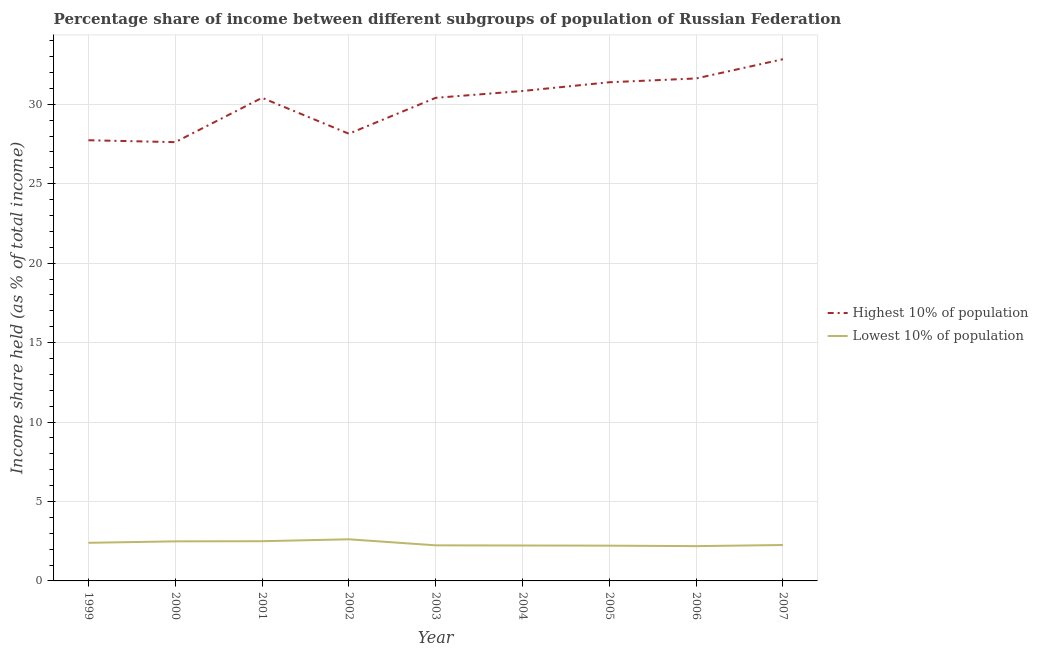Does the line corresponding to income share held by highest 10% of the population intersect with the line corresponding to income share held by lowest 10% of the population?
Make the answer very short. No. Is the number of lines equal to the number of legend labels?
Provide a succinct answer. Yes. What is the income share held by lowest 10% of the population in 2006?
Offer a very short reply. 2.19. Across all years, what is the maximum income share held by lowest 10% of the population?
Offer a very short reply. 2.62. Across all years, what is the minimum income share held by lowest 10% of the population?
Keep it short and to the point. 2.19. In which year was the income share held by lowest 10% of the population minimum?
Keep it short and to the point. 2006. What is the total income share held by lowest 10% of the population in the graph?
Make the answer very short. 21.15. What is the difference between the income share held by highest 10% of the population in 2004 and that in 2006?
Provide a succinct answer. -0.79. What is the difference between the income share held by highest 10% of the population in 2001 and the income share held by lowest 10% of the population in 2007?
Your answer should be compact. 28.15. What is the average income share held by lowest 10% of the population per year?
Your response must be concise. 2.35. In the year 2003, what is the difference between the income share held by lowest 10% of the population and income share held by highest 10% of the population?
Offer a very short reply. -28.17. What is the ratio of the income share held by lowest 10% of the population in 2000 to that in 2006?
Offer a terse response. 1.14. Is the income share held by highest 10% of the population in 2002 less than that in 2005?
Provide a short and direct response. Yes. Is the difference between the income share held by lowest 10% of the population in 2003 and 2006 greater than the difference between the income share held by highest 10% of the population in 2003 and 2006?
Offer a very short reply. Yes. What is the difference between the highest and the second highest income share held by highest 10% of the population?
Your response must be concise. 1.21. What is the difference between the highest and the lowest income share held by highest 10% of the population?
Ensure brevity in your answer.  5.22. Is the sum of the income share held by highest 10% of the population in 2001 and 2005 greater than the maximum income share held by lowest 10% of the population across all years?
Ensure brevity in your answer.  Yes. Does the income share held by highest 10% of the population monotonically increase over the years?
Make the answer very short. No. Is the income share held by highest 10% of the population strictly greater than the income share held by lowest 10% of the population over the years?
Offer a terse response. Yes. What is the difference between two consecutive major ticks on the Y-axis?
Your answer should be very brief. 5. Are the values on the major ticks of Y-axis written in scientific E-notation?
Offer a very short reply. No. Does the graph contain grids?
Give a very brief answer. Yes. Where does the legend appear in the graph?
Give a very brief answer. Center right. How are the legend labels stacked?
Provide a succinct answer. Vertical. What is the title of the graph?
Provide a short and direct response. Percentage share of income between different subgroups of population of Russian Federation. Does "Nonresident" appear as one of the legend labels in the graph?
Your answer should be very brief. No. What is the label or title of the Y-axis?
Your response must be concise. Income share held (as % of total income). What is the Income share held (as % of total income) of Highest 10% of population in 1999?
Provide a short and direct response. 27.74. What is the Income share held (as % of total income) in Highest 10% of population in 2000?
Your answer should be compact. 27.62. What is the Income share held (as % of total income) of Lowest 10% of population in 2000?
Provide a succinct answer. 2.49. What is the Income share held (as % of total income) of Highest 10% of population in 2001?
Offer a very short reply. 30.41. What is the Income share held (as % of total income) in Lowest 10% of population in 2001?
Keep it short and to the point. 2.5. What is the Income share held (as % of total income) of Highest 10% of population in 2002?
Ensure brevity in your answer.  28.15. What is the Income share held (as % of total income) of Lowest 10% of population in 2002?
Your answer should be very brief. 2.62. What is the Income share held (as % of total income) in Highest 10% of population in 2003?
Give a very brief answer. 30.41. What is the Income share held (as % of total income) in Lowest 10% of population in 2003?
Your answer should be compact. 2.24. What is the Income share held (as % of total income) of Highest 10% of population in 2004?
Ensure brevity in your answer.  30.84. What is the Income share held (as % of total income) in Lowest 10% of population in 2004?
Your response must be concise. 2.23. What is the Income share held (as % of total income) of Highest 10% of population in 2005?
Keep it short and to the point. 31.39. What is the Income share held (as % of total income) in Lowest 10% of population in 2005?
Your answer should be compact. 2.22. What is the Income share held (as % of total income) in Highest 10% of population in 2006?
Offer a terse response. 31.63. What is the Income share held (as % of total income) in Lowest 10% of population in 2006?
Give a very brief answer. 2.19. What is the Income share held (as % of total income) in Highest 10% of population in 2007?
Give a very brief answer. 32.84. What is the Income share held (as % of total income) of Lowest 10% of population in 2007?
Your response must be concise. 2.26. Across all years, what is the maximum Income share held (as % of total income) of Highest 10% of population?
Ensure brevity in your answer.  32.84. Across all years, what is the maximum Income share held (as % of total income) of Lowest 10% of population?
Make the answer very short. 2.62. Across all years, what is the minimum Income share held (as % of total income) of Highest 10% of population?
Ensure brevity in your answer.  27.62. Across all years, what is the minimum Income share held (as % of total income) of Lowest 10% of population?
Ensure brevity in your answer.  2.19. What is the total Income share held (as % of total income) of Highest 10% of population in the graph?
Make the answer very short. 271.03. What is the total Income share held (as % of total income) of Lowest 10% of population in the graph?
Offer a terse response. 21.15. What is the difference between the Income share held (as % of total income) in Highest 10% of population in 1999 and that in 2000?
Offer a terse response. 0.12. What is the difference between the Income share held (as % of total income) of Lowest 10% of population in 1999 and that in 2000?
Ensure brevity in your answer.  -0.09. What is the difference between the Income share held (as % of total income) in Highest 10% of population in 1999 and that in 2001?
Your answer should be very brief. -2.67. What is the difference between the Income share held (as % of total income) in Lowest 10% of population in 1999 and that in 2001?
Make the answer very short. -0.1. What is the difference between the Income share held (as % of total income) in Highest 10% of population in 1999 and that in 2002?
Provide a succinct answer. -0.41. What is the difference between the Income share held (as % of total income) in Lowest 10% of population in 1999 and that in 2002?
Your answer should be very brief. -0.22. What is the difference between the Income share held (as % of total income) of Highest 10% of population in 1999 and that in 2003?
Provide a succinct answer. -2.67. What is the difference between the Income share held (as % of total income) in Lowest 10% of population in 1999 and that in 2003?
Provide a short and direct response. 0.16. What is the difference between the Income share held (as % of total income) of Highest 10% of population in 1999 and that in 2004?
Provide a succinct answer. -3.1. What is the difference between the Income share held (as % of total income) of Lowest 10% of population in 1999 and that in 2004?
Keep it short and to the point. 0.17. What is the difference between the Income share held (as % of total income) of Highest 10% of population in 1999 and that in 2005?
Make the answer very short. -3.65. What is the difference between the Income share held (as % of total income) of Lowest 10% of population in 1999 and that in 2005?
Your answer should be compact. 0.18. What is the difference between the Income share held (as % of total income) of Highest 10% of population in 1999 and that in 2006?
Provide a short and direct response. -3.89. What is the difference between the Income share held (as % of total income) in Lowest 10% of population in 1999 and that in 2006?
Your answer should be compact. 0.21. What is the difference between the Income share held (as % of total income) in Lowest 10% of population in 1999 and that in 2007?
Make the answer very short. 0.14. What is the difference between the Income share held (as % of total income) in Highest 10% of population in 2000 and that in 2001?
Provide a succinct answer. -2.79. What is the difference between the Income share held (as % of total income) in Lowest 10% of population in 2000 and that in 2001?
Your answer should be very brief. -0.01. What is the difference between the Income share held (as % of total income) in Highest 10% of population in 2000 and that in 2002?
Provide a short and direct response. -0.53. What is the difference between the Income share held (as % of total income) in Lowest 10% of population in 2000 and that in 2002?
Provide a short and direct response. -0.13. What is the difference between the Income share held (as % of total income) in Highest 10% of population in 2000 and that in 2003?
Offer a terse response. -2.79. What is the difference between the Income share held (as % of total income) of Lowest 10% of population in 2000 and that in 2003?
Ensure brevity in your answer.  0.25. What is the difference between the Income share held (as % of total income) in Highest 10% of population in 2000 and that in 2004?
Make the answer very short. -3.22. What is the difference between the Income share held (as % of total income) of Lowest 10% of population in 2000 and that in 2004?
Provide a succinct answer. 0.26. What is the difference between the Income share held (as % of total income) in Highest 10% of population in 2000 and that in 2005?
Ensure brevity in your answer.  -3.77. What is the difference between the Income share held (as % of total income) of Lowest 10% of population in 2000 and that in 2005?
Ensure brevity in your answer.  0.27. What is the difference between the Income share held (as % of total income) of Highest 10% of population in 2000 and that in 2006?
Make the answer very short. -4.01. What is the difference between the Income share held (as % of total income) in Highest 10% of population in 2000 and that in 2007?
Your answer should be very brief. -5.22. What is the difference between the Income share held (as % of total income) in Lowest 10% of population in 2000 and that in 2007?
Provide a short and direct response. 0.23. What is the difference between the Income share held (as % of total income) in Highest 10% of population in 2001 and that in 2002?
Give a very brief answer. 2.26. What is the difference between the Income share held (as % of total income) in Lowest 10% of population in 2001 and that in 2002?
Make the answer very short. -0.12. What is the difference between the Income share held (as % of total income) of Highest 10% of population in 2001 and that in 2003?
Keep it short and to the point. 0. What is the difference between the Income share held (as % of total income) in Lowest 10% of population in 2001 and that in 2003?
Keep it short and to the point. 0.26. What is the difference between the Income share held (as % of total income) of Highest 10% of population in 2001 and that in 2004?
Your response must be concise. -0.43. What is the difference between the Income share held (as % of total income) in Lowest 10% of population in 2001 and that in 2004?
Provide a short and direct response. 0.27. What is the difference between the Income share held (as % of total income) in Highest 10% of population in 2001 and that in 2005?
Your answer should be compact. -0.98. What is the difference between the Income share held (as % of total income) of Lowest 10% of population in 2001 and that in 2005?
Provide a succinct answer. 0.28. What is the difference between the Income share held (as % of total income) of Highest 10% of population in 2001 and that in 2006?
Provide a short and direct response. -1.22. What is the difference between the Income share held (as % of total income) in Lowest 10% of population in 2001 and that in 2006?
Provide a short and direct response. 0.31. What is the difference between the Income share held (as % of total income) of Highest 10% of population in 2001 and that in 2007?
Make the answer very short. -2.43. What is the difference between the Income share held (as % of total income) in Lowest 10% of population in 2001 and that in 2007?
Ensure brevity in your answer.  0.24. What is the difference between the Income share held (as % of total income) of Highest 10% of population in 2002 and that in 2003?
Make the answer very short. -2.26. What is the difference between the Income share held (as % of total income) in Lowest 10% of population in 2002 and that in 2003?
Offer a terse response. 0.38. What is the difference between the Income share held (as % of total income) in Highest 10% of population in 2002 and that in 2004?
Offer a very short reply. -2.69. What is the difference between the Income share held (as % of total income) of Lowest 10% of population in 2002 and that in 2004?
Give a very brief answer. 0.39. What is the difference between the Income share held (as % of total income) of Highest 10% of population in 2002 and that in 2005?
Keep it short and to the point. -3.24. What is the difference between the Income share held (as % of total income) of Highest 10% of population in 2002 and that in 2006?
Your answer should be compact. -3.48. What is the difference between the Income share held (as % of total income) of Lowest 10% of population in 2002 and that in 2006?
Your answer should be very brief. 0.43. What is the difference between the Income share held (as % of total income) in Highest 10% of population in 2002 and that in 2007?
Your answer should be very brief. -4.69. What is the difference between the Income share held (as % of total income) in Lowest 10% of population in 2002 and that in 2007?
Ensure brevity in your answer.  0.36. What is the difference between the Income share held (as % of total income) in Highest 10% of population in 2003 and that in 2004?
Give a very brief answer. -0.43. What is the difference between the Income share held (as % of total income) of Lowest 10% of population in 2003 and that in 2004?
Keep it short and to the point. 0.01. What is the difference between the Income share held (as % of total income) of Highest 10% of population in 2003 and that in 2005?
Your answer should be very brief. -0.98. What is the difference between the Income share held (as % of total income) of Highest 10% of population in 2003 and that in 2006?
Make the answer very short. -1.22. What is the difference between the Income share held (as % of total income) in Lowest 10% of population in 2003 and that in 2006?
Provide a succinct answer. 0.05. What is the difference between the Income share held (as % of total income) in Highest 10% of population in 2003 and that in 2007?
Your answer should be very brief. -2.43. What is the difference between the Income share held (as % of total income) of Lowest 10% of population in 2003 and that in 2007?
Your answer should be very brief. -0.02. What is the difference between the Income share held (as % of total income) of Highest 10% of population in 2004 and that in 2005?
Offer a very short reply. -0.55. What is the difference between the Income share held (as % of total income) in Lowest 10% of population in 2004 and that in 2005?
Provide a short and direct response. 0.01. What is the difference between the Income share held (as % of total income) of Highest 10% of population in 2004 and that in 2006?
Ensure brevity in your answer.  -0.79. What is the difference between the Income share held (as % of total income) of Lowest 10% of population in 2004 and that in 2006?
Keep it short and to the point. 0.04. What is the difference between the Income share held (as % of total income) of Highest 10% of population in 2004 and that in 2007?
Offer a terse response. -2. What is the difference between the Income share held (as % of total income) in Lowest 10% of population in 2004 and that in 2007?
Your answer should be very brief. -0.03. What is the difference between the Income share held (as % of total income) in Highest 10% of population in 2005 and that in 2006?
Your answer should be very brief. -0.24. What is the difference between the Income share held (as % of total income) in Highest 10% of population in 2005 and that in 2007?
Make the answer very short. -1.45. What is the difference between the Income share held (as % of total income) of Lowest 10% of population in 2005 and that in 2007?
Offer a very short reply. -0.04. What is the difference between the Income share held (as % of total income) of Highest 10% of population in 2006 and that in 2007?
Ensure brevity in your answer.  -1.21. What is the difference between the Income share held (as % of total income) of Lowest 10% of population in 2006 and that in 2007?
Make the answer very short. -0.07. What is the difference between the Income share held (as % of total income) of Highest 10% of population in 1999 and the Income share held (as % of total income) of Lowest 10% of population in 2000?
Keep it short and to the point. 25.25. What is the difference between the Income share held (as % of total income) in Highest 10% of population in 1999 and the Income share held (as % of total income) in Lowest 10% of population in 2001?
Your response must be concise. 25.24. What is the difference between the Income share held (as % of total income) in Highest 10% of population in 1999 and the Income share held (as % of total income) in Lowest 10% of population in 2002?
Ensure brevity in your answer.  25.12. What is the difference between the Income share held (as % of total income) in Highest 10% of population in 1999 and the Income share held (as % of total income) in Lowest 10% of population in 2004?
Your response must be concise. 25.51. What is the difference between the Income share held (as % of total income) of Highest 10% of population in 1999 and the Income share held (as % of total income) of Lowest 10% of population in 2005?
Provide a short and direct response. 25.52. What is the difference between the Income share held (as % of total income) of Highest 10% of population in 1999 and the Income share held (as % of total income) of Lowest 10% of population in 2006?
Provide a short and direct response. 25.55. What is the difference between the Income share held (as % of total income) of Highest 10% of population in 1999 and the Income share held (as % of total income) of Lowest 10% of population in 2007?
Offer a very short reply. 25.48. What is the difference between the Income share held (as % of total income) in Highest 10% of population in 2000 and the Income share held (as % of total income) in Lowest 10% of population in 2001?
Provide a succinct answer. 25.12. What is the difference between the Income share held (as % of total income) in Highest 10% of population in 2000 and the Income share held (as % of total income) in Lowest 10% of population in 2003?
Provide a short and direct response. 25.38. What is the difference between the Income share held (as % of total income) in Highest 10% of population in 2000 and the Income share held (as % of total income) in Lowest 10% of population in 2004?
Offer a very short reply. 25.39. What is the difference between the Income share held (as % of total income) of Highest 10% of population in 2000 and the Income share held (as % of total income) of Lowest 10% of population in 2005?
Offer a very short reply. 25.4. What is the difference between the Income share held (as % of total income) in Highest 10% of population in 2000 and the Income share held (as % of total income) in Lowest 10% of population in 2006?
Your answer should be compact. 25.43. What is the difference between the Income share held (as % of total income) in Highest 10% of population in 2000 and the Income share held (as % of total income) in Lowest 10% of population in 2007?
Your answer should be very brief. 25.36. What is the difference between the Income share held (as % of total income) of Highest 10% of population in 2001 and the Income share held (as % of total income) of Lowest 10% of population in 2002?
Ensure brevity in your answer.  27.79. What is the difference between the Income share held (as % of total income) in Highest 10% of population in 2001 and the Income share held (as % of total income) in Lowest 10% of population in 2003?
Offer a terse response. 28.17. What is the difference between the Income share held (as % of total income) of Highest 10% of population in 2001 and the Income share held (as % of total income) of Lowest 10% of population in 2004?
Offer a terse response. 28.18. What is the difference between the Income share held (as % of total income) of Highest 10% of population in 2001 and the Income share held (as % of total income) of Lowest 10% of population in 2005?
Offer a very short reply. 28.19. What is the difference between the Income share held (as % of total income) in Highest 10% of population in 2001 and the Income share held (as % of total income) in Lowest 10% of population in 2006?
Your answer should be compact. 28.22. What is the difference between the Income share held (as % of total income) of Highest 10% of population in 2001 and the Income share held (as % of total income) of Lowest 10% of population in 2007?
Keep it short and to the point. 28.15. What is the difference between the Income share held (as % of total income) in Highest 10% of population in 2002 and the Income share held (as % of total income) in Lowest 10% of population in 2003?
Give a very brief answer. 25.91. What is the difference between the Income share held (as % of total income) of Highest 10% of population in 2002 and the Income share held (as % of total income) of Lowest 10% of population in 2004?
Provide a succinct answer. 25.92. What is the difference between the Income share held (as % of total income) in Highest 10% of population in 2002 and the Income share held (as % of total income) in Lowest 10% of population in 2005?
Your answer should be very brief. 25.93. What is the difference between the Income share held (as % of total income) of Highest 10% of population in 2002 and the Income share held (as % of total income) of Lowest 10% of population in 2006?
Offer a very short reply. 25.96. What is the difference between the Income share held (as % of total income) in Highest 10% of population in 2002 and the Income share held (as % of total income) in Lowest 10% of population in 2007?
Offer a terse response. 25.89. What is the difference between the Income share held (as % of total income) in Highest 10% of population in 2003 and the Income share held (as % of total income) in Lowest 10% of population in 2004?
Your response must be concise. 28.18. What is the difference between the Income share held (as % of total income) of Highest 10% of population in 2003 and the Income share held (as % of total income) of Lowest 10% of population in 2005?
Give a very brief answer. 28.19. What is the difference between the Income share held (as % of total income) of Highest 10% of population in 2003 and the Income share held (as % of total income) of Lowest 10% of population in 2006?
Make the answer very short. 28.22. What is the difference between the Income share held (as % of total income) of Highest 10% of population in 2003 and the Income share held (as % of total income) of Lowest 10% of population in 2007?
Give a very brief answer. 28.15. What is the difference between the Income share held (as % of total income) in Highest 10% of population in 2004 and the Income share held (as % of total income) in Lowest 10% of population in 2005?
Provide a short and direct response. 28.62. What is the difference between the Income share held (as % of total income) in Highest 10% of population in 2004 and the Income share held (as % of total income) in Lowest 10% of population in 2006?
Your answer should be compact. 28.65. What is the difference between the Income share held (as % of total income) in Highest 10% of population in 2004 and the Income share held (as % of total income) in Lowest 10% of population in 2007?
Offer a terse response. 28.58. What is the difference between the Income share held (as % of total income) in Highest 10% of population in 2005 and the Income share held (as % of total income) in Lowest 10% of population in 2006?
Provide a succinct answer. 29.2. What is the difference between the Income share held (as % of total income) in Highest 10% of population in 2005 and the Income share held (as % of total income) in Lowest 10% of population in 2007?
Your answer should be very brief. 29.13. What is the difference between the Income share held (as % of total income) of Highest 10% of population in 2006 and the Income share held (as % of total income) of Lowest 10% of population in 2007?
Offer a very short reply. 29.37. What is the average Income share held (as % of total income) in Highest 10% of population per year?
Offer a very short reply. 30.11. What is the average Income share held (as % of total income) of Lowest 10% of population per year?
Provide a succinct answer. 2.35. In the year 1999, what is the difference between the Income share held (as % of total income) of Highest 10% of population and Income share held (as % of total income) of Lowest 10% of population?
Give a very brief answer. 25.34. In the year 2000, what is the difference between the Income share held (as % of total income) of Highest 10% of population and Income share held (as % of total income) of Lowest 10% of population?
Your answer should be very brief. 25.13. In the year 2001, what is the difference between the Income share held (as % of total income) of Highest 10% of population and Income share held (as % of total income) of Lowest 10% of population?
Offer a terse response. 27.91. In the year 2002, what is the difference between the Income share held (as % of total income) of Highest 10% of population and Income share held (as % of total income) of Lowest 10% of population?
Provide a succinct answer. 25.53. In the year 2003, what is the difference between the Income share held (as % of total income) of Highest 10% of population and Income share held (as % of total income) of Lowest 10% of population?
Provide a short and direct response. 28.17. In the year 2004, what is the difference between the Income share held (as % of total income) in Highest 10% of population and Income share held (as % of total income) in Lowest 10% of population?
Keep it short and to the point. 28.61. In the year 2005, what is the difference between the Income share held (as % of total income) in Highest 10% of population and Income share held (as % of total income) in Lowest 10% of population?
Make the answer very short. 29.17. In the year 2006, what is the difference between the Income share held (as % of total income) in Highest 10% of population and Income share held (as % of total income) in Lowest 10% of population?
Give a very brief answer. 29.44. In the year 2007, what is the difference between the Income share held (as % of total income) in Highest 10% of population and Income share held (as % of total income) in Lowest 10% of population?
Provide a short and direct response. 30.58. What is the ratio of the Income share held (as % of total income) of Lowest 10% of population in 1999 to that in 2000?
Make the answer very short. 0.96. What is the ratio of the Income share held (as % of total income) in Highest 10% of population in 1999 to that in 2001?
Offer a very short reply. 0.91. What is the ratio of the Income share held (as % of total income) of Highest 10% of population in 1999 to that in 2002?
Ensure brevity in your answer.  0.99. What is the ratio of the Income share held (as % of total income) of Lowest 10% of population in 1999 to that in 2002?
Keep it short and to the point. 0.92. What is the ratio of the Income share held (as % of total income) of Highest 10% of population in 1999 to that in 2003?
Keep it short and to the point. 0.91. What is the ratio of the Income share held (as % of total income) of Lowest 10% of population in 1999 to that in 2003?
Keep it short and to the point. 1.07. What is the ratio of the Income share held (as % of total income) of Highest 10% of population in 1999 to that in 2004?
Ensure brevity in your answer.  0.9. What is the ratio of the Income share held (as % of total income) of Lowest 10% of population in 1999 to that in 2004?
Your answer should be very brief. 1.08. What is the ratio of the Income share held (as % of total income) in Highest 10% of population in 1999 to that in 2005?
Your response must be concise. 0.88. What is the ratio of the Income share held (as % of total income) of Lowest 10% of population in 1999 to that in 2005?
Provide a succinct answer. 1.08. What is the ratio of the Income share held (as % of total income) in Highest 10% of population in 1999 to that in 2006?
Give a very brief answer. 0.88. What is the ratio of the Income share held (as % of total income) in Lowest 10% of population in 1999 to that in 2006?
Make the answer very short. 1.1. What is the ratio of the Income share held (as % of total income) of Highest 10% of population in 1999 to that in 2007?
Provide a short and direct response. 0.84. What is the ratio of the Income share held (as % of total income) of Lowest 10% of population in 1999 to that in 2007?
Your answer should be compact. 1.06. What is the ratio of the Income share held (as % of total income) in Highest 10% of population in 2000 to that in 2001?
Your answer should be compact. 0.91. What is the ratio of the Income share held (as % of total income) of Lowest 10% of population in 2000 to that in 2001?
Your response must be concise. 1. What is the ratio of the Income share held (as % of total income) in Highest 10% of population in 2000 to that in 2002?
Offer a very short reply. 0.98. What is the ratio of the Income share held (as % of total income) in Lowest 10% of population in 2000 to that in 2002?
Offer a very short reply. 0.95. What is the ratio of the Income share held (as % of total income) in Highest 10% of population in 2000 to that in 2003?
Make the answer very short. 0.91. What is the ratio of the Income share held (as % of total income) in Lowest 10% of population in 2000 to that in 2003?
Make the answer very short. 1.11. What is the ratio of the Income share held (as % of total income) in Highest 10% of population in 2000 to that in 2004?
Make the answer very short. 0.9. What is the ratio of the Income share held (as % of total income) in Lowest 10% of population in 2000 to that in 2004?
Provide a short and direct response. 1.12. What is the ratio of the Income share held (as % of total income) in Highest 10% of population in 2000 to that in 2005?
Offer a terse response. 0.88. What is the ratio of the Income share held (as % of total income) of Lowest 10% of population in 2000 to that in 2005?
Give a very brief answer. 1.12. What is the ratio of the Income share held (as % of total income) in Highest 10% of population in 2000 to that in 2006?
Provide a short and direct response. 0.87. What is the ratio of the Income share held (as % of total income) in Lowest 10% of population in 2000 to that in 2006?
Offer a very short reply. 1.14. What is the ratio of the Income share held (as % of total income) in Highest 10% of population in 2000 to that in 2007?
Your answer should be compact. 0.84. What is the ratio of the Income share held (as % of total income) in Lowest 10% of population in 2000 to that in 2007?
Keep it short and to the point. 1.1. What is the ratio of the Income share held (as % of total income) of Highest 10% of population in 2001 to that in 2002?
Your answer should be compact. 1.08. What is the ratio of the Income share held (as % of total income) of Lowest 10% of population in 2001 to that in 2002?
Give a very brief answer. 0.95. What is the ratio of the Income share held (as % of total income) of Highest 10% of population in 2001 to that in 2003?
Your response must be concise. 1. What is the ratio of the Income share held (as % of total income) in Lowest 10% of population in 2001 to that in 2003?
Your response must be concise. 1.12. What is the ratio of the Income share held (as % of total income) of Highest 10% of population in 2001 to that in 2004?
Keep it short and to the point. 0.99. What is the ratio of the Income share held (as % of total income) of Lowest 10% of population in 2001 to that in 2004?
Offer a very short reply. 1.12. What is the ratio of the Income share held (as % of total income) in Highest 10% of population in 2001 to that in 2005?
Your answer should be very brief. 0.97. What is the ratio of the Income share held (as % of total income) of Lowest 10% of population in 2001 to that in 2005?
Make the answer very short. 1.13. What is the ratio of the Income share held (as % of total income) in Highest 10% of population in 2001 to that in 2006?
Make the answer very short. 0.96. What is the ratio of the Income share held (as % of total income) in Lowest 10% of population in 2001 to that in 2006?
Your answer should be compact. 1.14. What is the ratio of the Income share held (as % of total income) of Highest 10% of population in 2001 to that in 2007?
Offer a very short reply. 0.93. What is the ratio of the Income share held (as % of total income) in Lowest 10% of population in 2001 to that in 2007?
Offer a very short reply. 1.11. What is the ratio of the Income share held (as % of total income) of Highest 10% of population in 2002 to that in 2003?
Provide a succinct answer. 0.93. What is the ratio of the Income share held (as % of total income) in Lowest 10% of population in 2002 to that in 2003?
Provide a short and direct response. 1.17. What is the ratio of the Income share held (as % of total income) in Highest 10% of population in 2002 to that in 2004?
Give a very brief answer. 0.91. What is the ratio of the Income share held (as % of total income) in Lowest 10% of population in 2002 to that in 2004?
Ensure brevity in your answer.  1.17. What is the ratio of the Income share held (as % of total income) in Highest 10% of population in 2002 to that in 2005?
Offer a terse response. 0.9. What is the ratio of the Income share held (as % of total income) of Lowest 10% of population in 2002 to that in 2005?
Keep it short and to the point. 1.18. What is the ratio of the Income share held (as % of total income) in Highest 10% of population in 2002 to that in 2006?
Provide a succinct answer. 0.89. What is the ratio of the Income share held (as % of total income) of Lowest 10% of population in 2002 to that in 2006?
Offer a terse response. 1.2. What is the ratio of the Income share held (as % of total income) in Highest 10% of population in 2002 to that in 2007?
Provide a short and direct response. 0.86. What is the ratio of the Income share held (as % of total income) in Lowest 10% of population in 2002 to that in 2007?
Make the answer very short. 1.16. What is the ratio of the Income share held (as % of total income) in Highest 10% of population in 2003 to that in 2004?
Your answer should be compact. 0.99. What is the ratio of the Income share held (as % of total income) in Lowest 10% of population in 2003 to that in 2004?
Offer a terse response. 1. What is the ratio of the Income share held (as % of total income) of Highest 10% of population in 2003 to that in 2005?
Provide a short and direct response. 0.97. What is the ratio of the Income share held (as % of total income) in Highest 10% of population in 2003 to that in 2006?
Give a very brief answer. 0.96. What is the ratio of the Income share held (as % of total income) of Lowest 10% of population in 2003 to that in 2006?
Keep it short and to the point. 1.02. What is the ratio of the Income share held (as % of total income) in Highest 10% of population in 2003 to that in 2007?
Your answer should be very brief. 0.93. What is the ratio of the Income share held (as % of total income) of Lowest 10% of population in 2003 to that in 2007?
Offer a very short reply. 0.99. What is the ratio of the Income share held (as % of total income) in Highest 10% of population in 2004 to that in 2005?
Keep it short and to the point. 0.98. What is the ratio of the Income share held (as % of total income) of Lowest 10% of population in 2004 to that in 2006?
Provide a short and direct response. 1.02. What is the ratio of the Income share held (as % of total income) of Highest 10% of population in 2004 to that in 2007?
Offer a terse response. 0.94. What is the ratio of the Income share held (as % of total income) in Lowest 10% of population in 2004 to that in 2007?
Provide a succinct answer. 0.99. What is the ratio of the Income share held (as % of total income) of Highest 10% of population in 2005 to that in 2006?
Your response must be concise. 0.99. What is the ratio of the Income share held (as % of total income) in Lowest 10% of population in 2005 to that in 2006?
Give a very brief answer. 1.01. What is the ratio of the Income share held (as % of total income) in Highest 10% of population in 2005 to that in 2007?
Your answer should be very brief. 0.96. What is the ratio of the Income share held (as % of total income) in Lowest 10% of population in 2005 to that in 2007?
Give a very brief answer. 0.98. What is the ratio of the Income share held (as % of total income) in Highest 10% of population in 2006 to that in 2007?
Your answer should be very brief. 0.96. What is the ratio of the Income share held (as % of total income) of Lowest 10% of population in 2006 to that in 2007?
Offer a very short reply. 0.97. What is the difference between the highest and the second highest Income share held (as % of total income) in Highest 10% of population?
Your answer should be compact. 1.21. What is the difference between the highest and the second highest Income share held (as % of total income) in Lowest 10% of population?
Your answer should be very brief. 0.12. What is the difference between the highest and the lowest Income share held (as % of total income) in Highest 10% of population?
Provide a succinct answer. 5.22. What is the difference between the highest and the lowest Income share held (as % of total income) of Lowest 10% of population?
Your answer should be very brief. 0.43. 